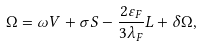<formula> <loc_0><loc_0><loc_500><loc_500>\Omega = \omega V + \sigma S - \frac { 2 \varepsilon _ { F } } { 3 \lambda _ { F } } L + \delta \Omega ,</formula> 